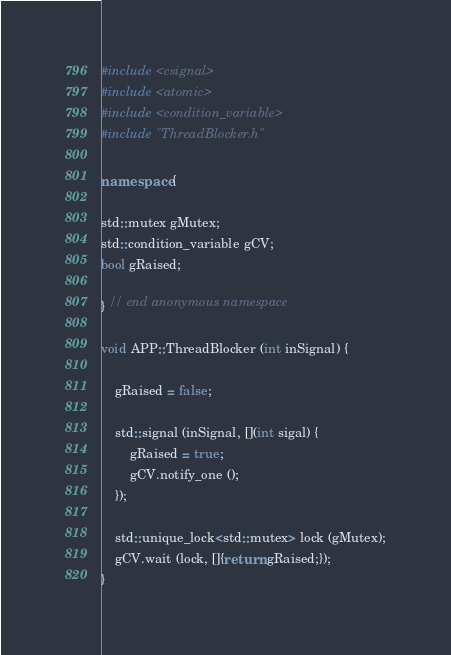<code> <loc_0><loc_0><loc_500><loc_500><_C++_>
#include <csignal>
#include <atomic>
#include <condition_variable>
#include "ThreadBlocker.h"

namespace {

std::mutex gMutex;
std::condition_variable gCV;
bool gRaised;

} // end anonymous namespace

void APP::ThreadBlocker (int inSignal) {
    
    gRaised = false;
    
    std::signal (inSignal, [](int sigal) {
        gRaised = true;
        gCV.notify_one ();
    });
    
    std::unique_lock<std::mutex> lock (gMutex);
    gCV.wait (lock, []{return gRaised;});
}
</code> 